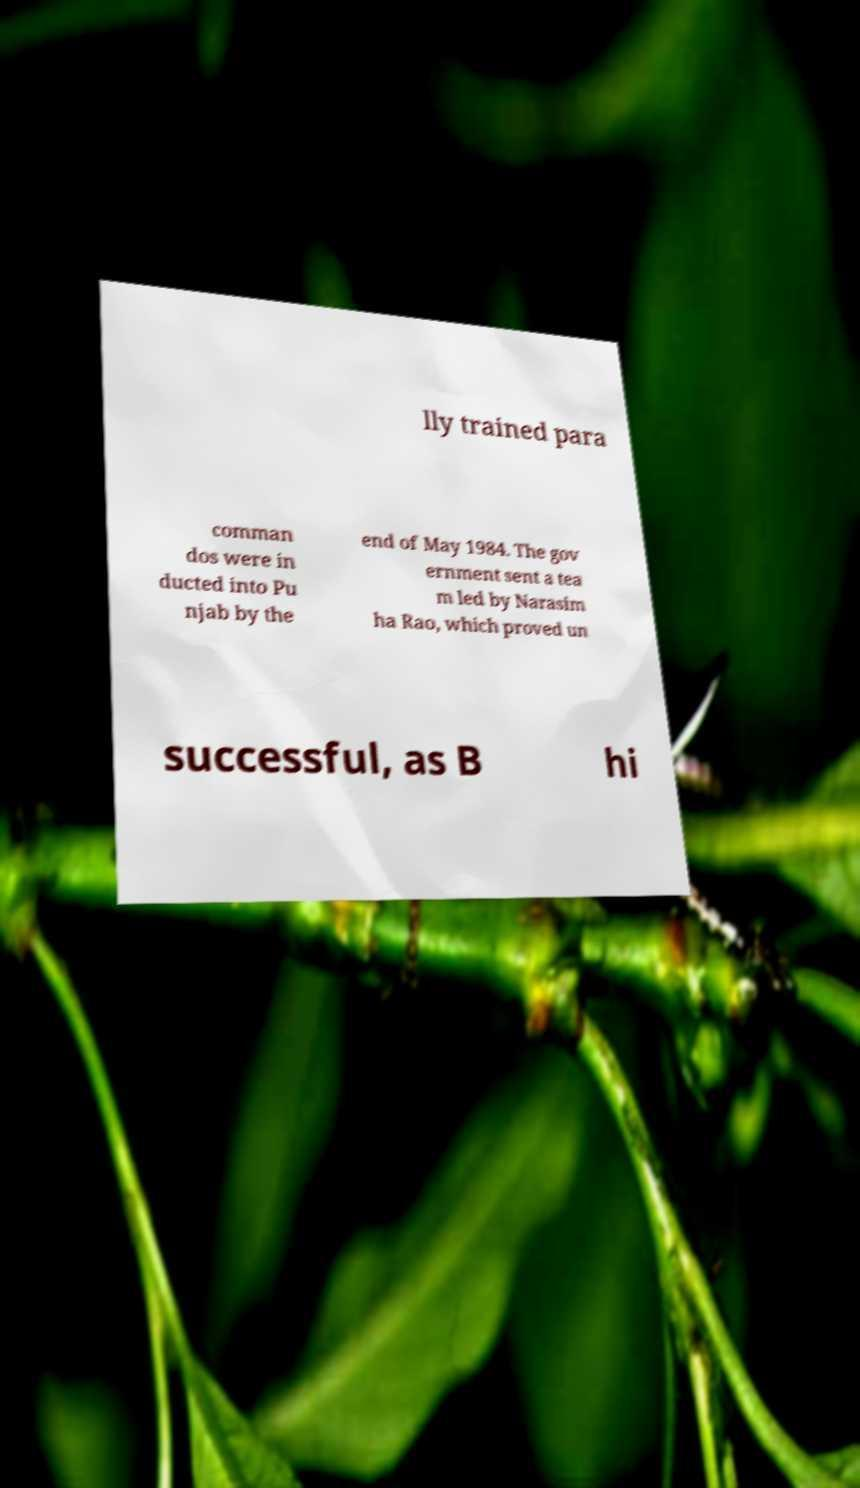What messages or text are displayed in this image? I need them in a readable, typed format. lly trained para comman dos were in ducted into Pu njab by the end of May 1984. The gov ernment sent a tea m led by Narasim ha Rao, which proved un successful, as B hi 